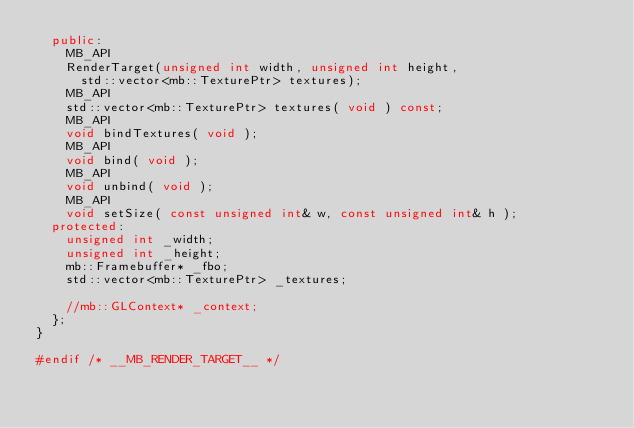<code> <loc_0><loc_0><loc_500><loc_500><_C++_>  public:
    MB_API
    RenderTarget(unsigned int width, unsigned int height,
      std::vector<mb::TexturePtr> textures);
    MB_API
    std::vector<mb::TexturePtr> textures( void ) const;
    MB_API
    void bindTextures( void );
    MB_API
    void bind( void );
    MB_API
    void unbind( void );
    MB_API
    void setSize( const unsigned int& w, const unsigned int& h );
  protected:
    unsigned int _width;
    unsigned int _height;
    mb::Framebuffer* _fbo;
    std::vector<mb::TexturePtr> _textures;

    //mb::GLContext* _context;
  };
}

#endif /* __MB_RENDER_TARGET__ */
</code> 